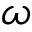<formula> <loc_0><loc_0><loc_500><loc_500>\omega</formula> 